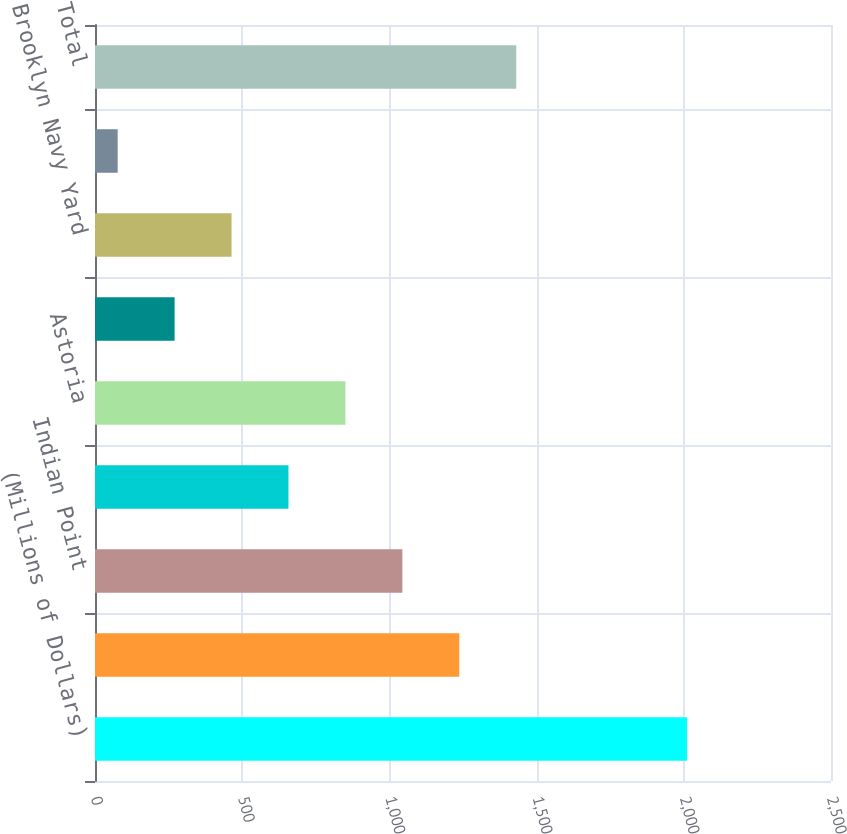Convert chart to OTSL. <chart><loc_0><loc_0><loc_500><loc_500><bar_chart><fcel>(Millions of Dollars)<fcel>Linden<fcel>Indian Point<fcel>Selkirk<fcel>Astoria<fcel>Independence<fcel>Brooklyn Navy Yard<fcel>Indeck Corinth<fcel>Total<nl><fcel>2011<fcel>1237.4<fcel>1044<fcel>657.2<fcel>850.6<fcel>270.4<fcel>463.8<fcel>77<fcel>1430.8<nl></chart> 